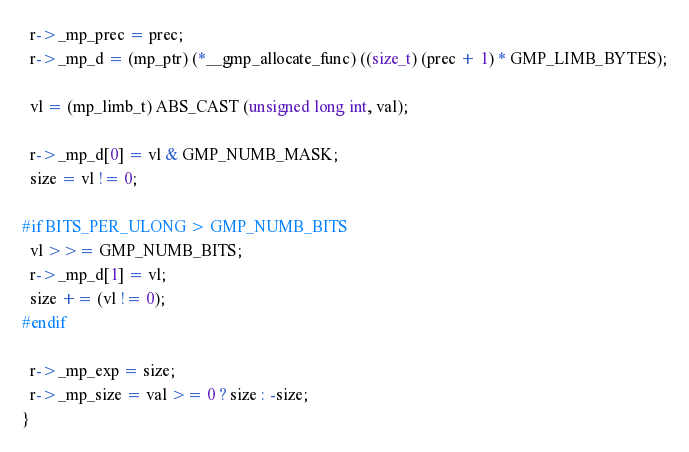<code> <loc_0><loc_0><loc_500><loc_500><_C_>
  r->_mp_prec = prec;
  r->_mp_d = (mp_ptr) (*__gmp_allocate_func) ((size_t) (prec + 1) * GMP_LIMB_BYTES);

  vl = (mp_limb_t) ABS_CAST (unsigned long int, val);

  r->_mp_d[0] = vl & GMP_NUMB_MASK;
  size = vl != 0;

#if BITS_PER_ULONG > GMP_NUMB_BITS
  vl >>= GMP_NUMB_BITS;
  r->_mp_d[1] = vl;
  size += (vl != 0);
#endif

  r->_mp_exp = size;
  r->_mp_size = val >= 0 ? size : -size;
}
</code> 